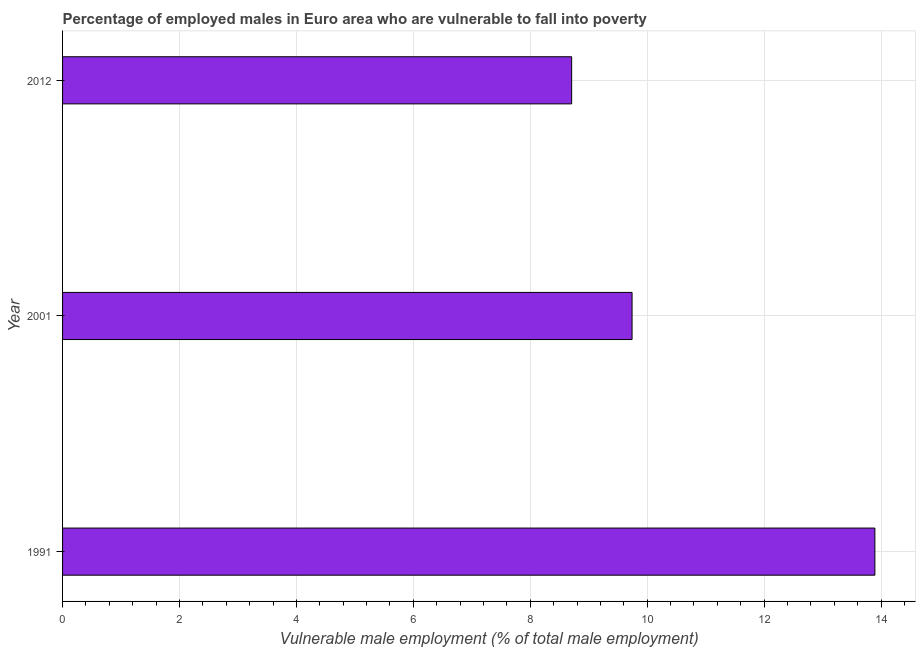What is the title of the graph?
Your answer should be very brief. Percentage of employed males in Euro area who are vulnerable to fall into poverty. What is the label or title of the X-axis?
Make the answer very short. Vulnerable male employment (% of total male employment). What is the label or title of the Y-axis?
Keep it short and to the point. Year. What is the percentage of employed males who are vulnerable to fall into poverty in 2001?
Offer a terse response. 9.74. Across all years, what is the maximum percentage of employed males who are vulnerable to fall into poverty?
Your response must be concise. 13.89. Across all years, what is the minimum percentage of employed males who are vulnerable to fall into poverty?
Ensure brevity in your answer.  8.71. In which year was the percentage of employed males who are vulnerable to fall into poverty maximum?
Provide a succinct answer. 1991. In which year was the percentage of employed males who are vulnerable to fall into poverty minimum?
Offer a very short reply. 2012. What is the sum of the percentage of employed males who are vulnerable to fall into poverty?
Offer a very short reply. 32.34. What is the difference between the percentage of employed males who are vulnerable to fall into poverty in 2001 and 2012?
Offer a very short reply. 1.03. What is the average percentage of employed males who are vulnerable to fall into poverty per year?
Offer a terse response. 10.78. What is the median percentage of employed males who are vulnerable to fall into poverty?
Provide a succinct answer. 9.74. Do a majority of the years between 1991 and 2001 (inclusive) have percentage of employed males who are vulnerable to fall into poverty greater than 12.4 %?
Make the answer very short. No. What is the ratio of the percentage of employed males who are vulnerable to fall into poverty in 2001 to that in 2012?
Make the answer very short. 1.12. Is the percentage of employed males who are vulnerable to fall into poverty in 1991 less than that in 2012?
Make the answer very short. No. Is the difference between the percentage of employed males who are vulnerable to fall into poverty in 1991 and 2001 greater than the difference between any two years?
Your answer should be compact. No. What is the difference between the highest and the second highest percentage of employed males who are vulnerable to fall into poverty?
Your answer should be very brief. 4.15. What is the difference between the highest and the lowest percentage of employed males who are vulnerable to fall into poverty?
Offer a very short reply. 5.19. In how many years, is the percentage of employed males who are vulnerable to fall into poverty greater than the average percentage of employed males who are vulnerable to fall into poverty taken over all years?
Give a very brief answer. 1. Are all the bars in the graph horizontal?
Give a very brief answer. Yes. What is the difference between two consecutive major ticks on the X-axis?
Your response must be concise. 2. What is the Vulnerable male employment (% of total male employment) in 1991?
Provide a short and direct response. 13.89. What is the Vulnerable male employment (% of total male employment) of 2001?
Provide a short and direct response. 9.74. What is the Vulnerable male employment (% of total male employment) in 2012?
Provide a succinct answer. 8.71. What is the difference between the Vulnerable male employment (% of total male employment) in 1991 and 2001?
Give a very brief answer. 4.15. What is the difference between the Vulnerable male employment (% of total male employment) in 1991 and 2012?
Provide a succinct answer. 5.19. What is the difference between the Vulnerable male employment (% of total male employment) in 2001 and 2012?
Provide a short and direct response. 1.03. What is the ratio of the Vulnerable male employment (% of total male employment) in 1991 to that in 2001?
Offer a very short reply. 1.43. What is the ratio of the Vulnerable male employment (% of total male employment) in 1991 to that in 2012?
Make the answer very short. 1.6. What is the ratio of the Vulnerable male employment (% of total male employment) in 2001 to that in 2012?
Your response must be concise. 1.12. 